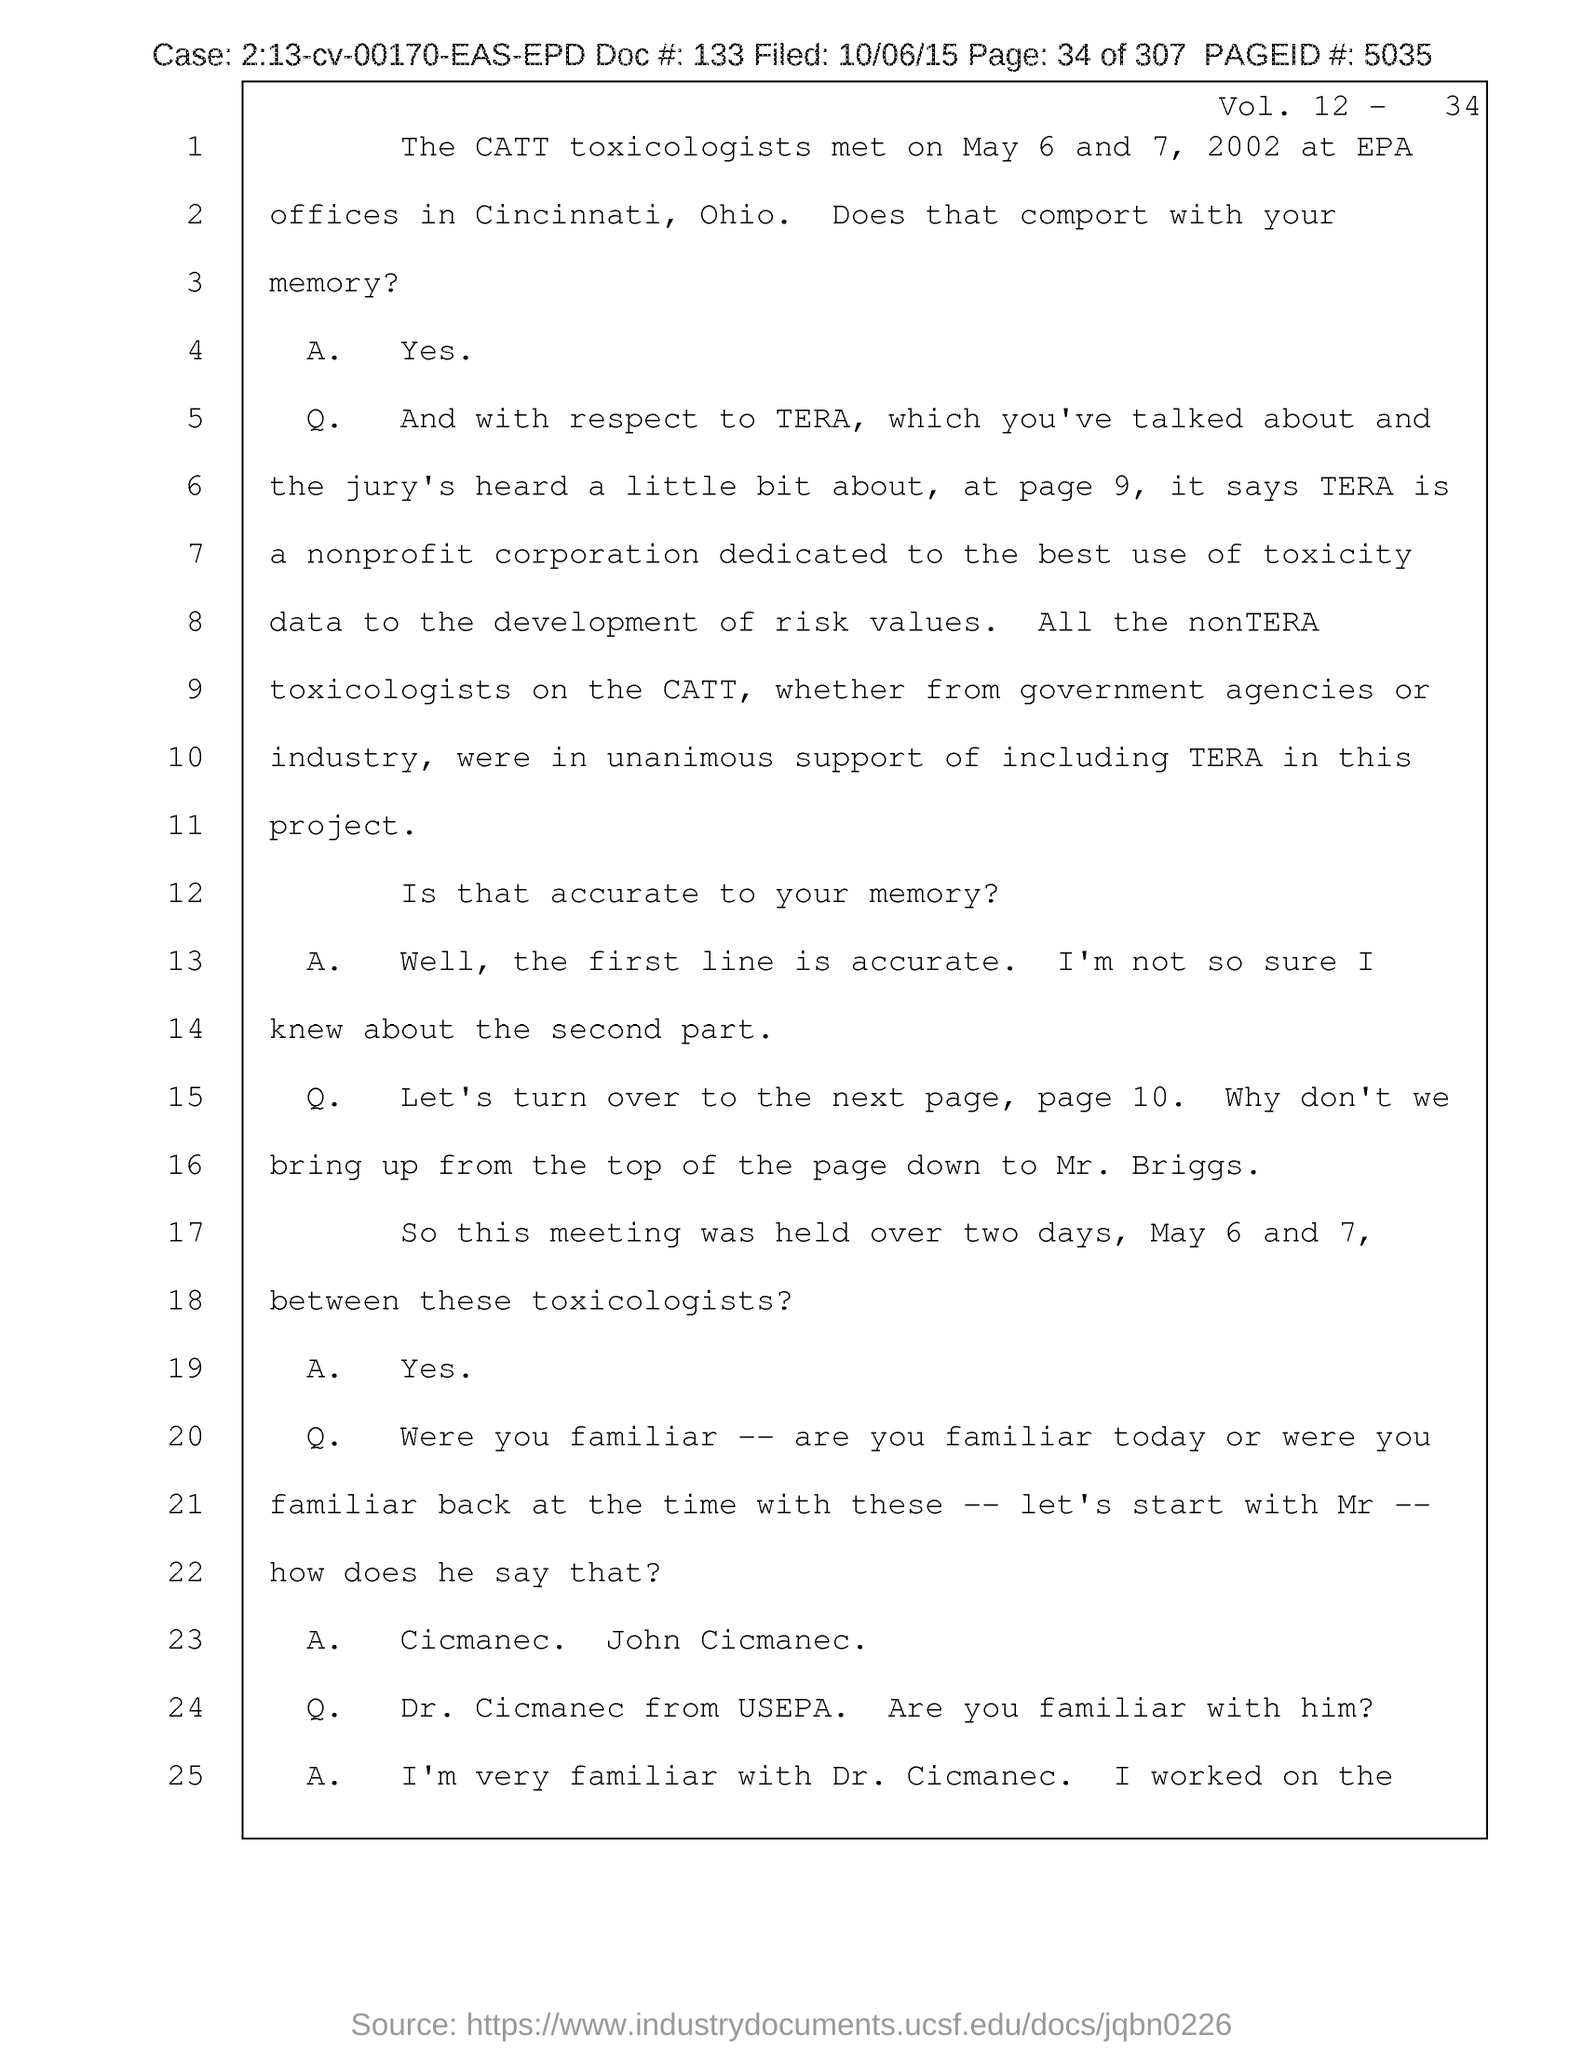What is the volume number?
Your answer should be compact. Vol. 12. 